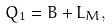Convert formula to latex. <formula><loc_0><loc_0><loc_500><loc_500>Q _ { 1 } = B + L _ { M } ,</formula> 